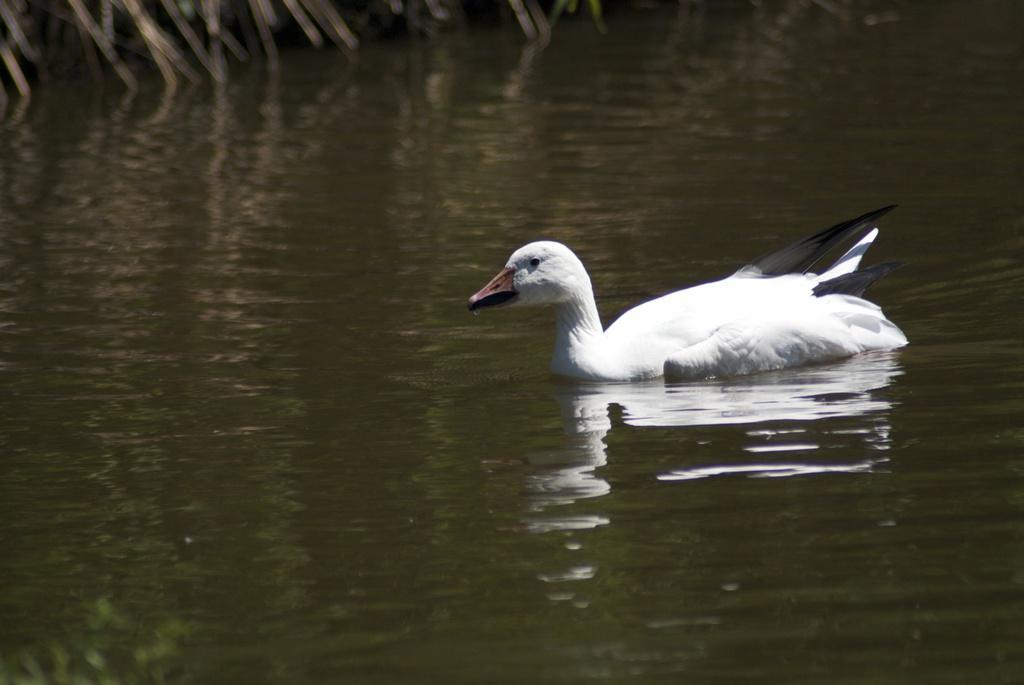Can you describe this image briefly? Here we can see water and duck. 